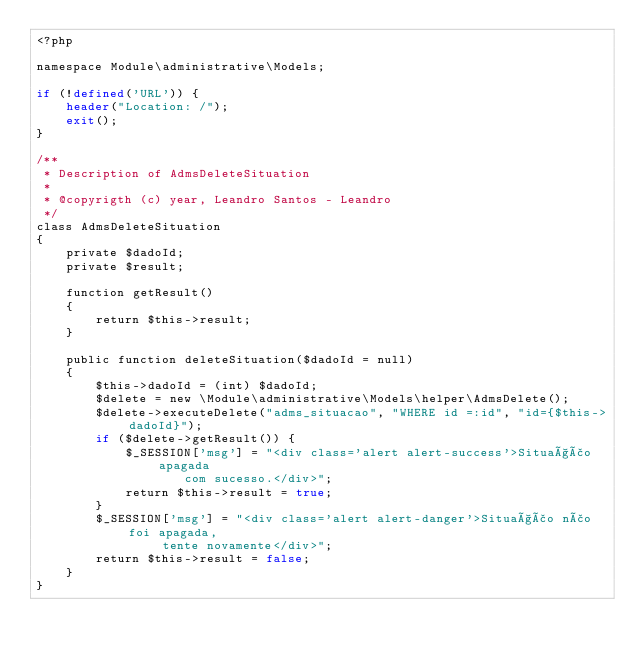Convert code to text. <code><loc_0><loc_0><loc_500><loc_500><_PHP_><?php

namespace Module\administrative\Models;

if (!defined('URL')) {
    header("Location: /");
    exit();
}

/**
 * Description of AdmsDeleteSituation
 *
 * @copyrigth (c) year, Leandro Santos - Leandro
 */
class AdmsDeleteSituation
{
    private $dadoId;
    private $result;
    
    function getResult()
    {
        return $this->result;
    }

    public function deleteSituation($dadoId = null)
    {
        $this->dadoId = (int) $dadoId;
        $delete = new \Module\administrative\Models\helper\AdmsDelete();
        $delete->executeDelete("adms_situacao", "WHERE id =:id", "id={$this->dadoId}");
        if ($delete->getResult()) {
            $_SESSION['msg'] = "<div class='alert alert-success'>Situação apagada 
                    com sucesso.</div>";
            return $this->result = true;
        }
        $_SESSION['msg'] = "<div class='alert alert-danger'>Situação não foi apagada,
                 tente novamente</div>";
        return $this->result = false;
    }
}
</code> 